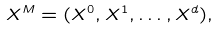<formula> <loc_0><loc_0><loc_500><loc_500>X ^ { M } = ( X ^ { 0 } , X ^ { 1 } , \dots , X ^ { d } ) ,</formula> 